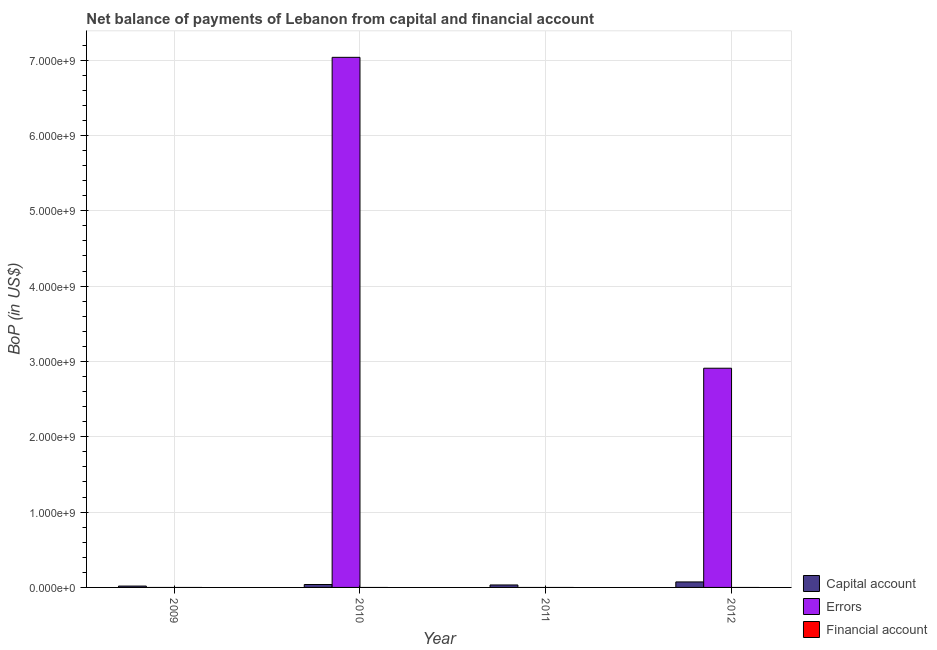Are the number of bars per tick equal to the number of legend labels?
Your answer should be very brief. No. Are the number of bars on each tick of the X-axis equal?
Make the answer very short. No. Across all years, what is the maximum amount of errors?
Keep it short and to the point. 7.04e+09. Across all years, what is the minimum amount of net capital account?
Offer a very short reply. 1.80e+07. What is the total amount of financial account in the graph?
Make the answer very short. 0. What is the difference between the amount of errors in 2010 and that in 2012?
Provide a succinct answer. 4.13e+09. What is the average amount of net capital account per year?
Your answer should be very brief. 4.07e+07. In the year 2009, what is the difference between the amount of net capital account and amount of financial account?
Offer a terse response. 0. In how many years, is the amount of net capital account greater than 1000000000 US$?
Your answer should be compact. 0. What is the ratio of the amount of net capital account in 2010 to that in 2011?
Give a very brief answer. 1.18. What is the difference between the highest and the lowest amount of errors?
Your response must be concise. 7.04e+09. In how many years, is the amount of financial account greater than the average amount of financial account taken over all years?
Keep it short and to the point. 0. Is it the case that in every year, the sum of the amount of net capital account and amount of errors is greater than the amount of financial account?
Offer a very short reply. Yes. Are all the bars in the graph horizontal?
Provide a succinct answer. No. How many years are there in the graph?
Make the answer very short. 4. What is the difference between two consecutive major ticks on the Y-axis?
Provide a short and direct response. 1.00e+09. Where does the legend appear in the graph?
Offer a very short reply. Bottom right. How many legend labels are there?
Your answer should be very brief. 3. What is the title of the graph?
Your answer should be compact. Net balance of payments of Lebanon from capital and financial account. Does "Renewable sources" appear as one of the legend labels in the graph?
Ensure brevity in your answer.  No. What is the label or title of the Y-axis?
Provide a short and direct response. BoP (in US$). What is the BoP (in US$) in Capital account in 2009?
Offer a terse response. 1.80e+07. What is the BoP (in US$) in Errors in 2009?
Offer a very short reply. 0. What is the BoP (in US$) in Capital account in 2010?
Offer a very short reply. 3.88e+07. What is the BoP (in US$) of Errors in 2010?
Ensure brevity in your answer.  7.04e+09. What is the BoP (in US$) in Capital account in 2011?
Offer a terse response. 3.28e+07. What is the BoP (in US$) in Errors in 2011?
Your response must be concise. 0. What is the BoP (in US$) of Capital account in 2012?
Your response must be concise. 7.31e+07. What is the BoP (in US$) of Errors in 2012?
Your answer should be compact. 2.91e+09. What is the BoP (in US$) in Financial account in 2012?
Ensure brevity in your answer.  0. Across all years, what is the maximum BoP (in US$) in Capital account?
Your answer should be very brief. 7.31e+07. Across all years, what is the maximum BoP (in US$) of Errors?
Your answer should be compact. 7.04e+09. Across all years, what is the minimum BoP (in US$) in Capital account?
Ensure brevity in your answer.  1.80e+07. Across all years, what is the minimum BoP (in US$) of Errors?
Give a very brief answer. 0. What is the total BoP (in US$) in Capital account in the graph?
Make the answer very short. 1.63e+08. What is the total BoP (in US$) of Errors in the graph?
Provide a succinct answer. 9.95e+09. What is the total BoP (in US$) of Financial account in the graph?
Provide a succinct answer. 0. What is the difference between the BoP (in US$) in Capital account in 2009 and that in 2010?
Your answer should be very brief. -2.09e+07. What is the difference between the BoP (in US$) in Capital account in 2009 and that in 2011?
Offer a very short reply. -1.48e+07. What is the difference between the BoP (in US$) in Capital account in 2009 and that in 2012?
Make the answer very short. -5.51e+07. What is the difference between the BoP (in US$) of Capital account in 2010 and that in 2011?
Provide a succinct answer. 6.05e+06. What is the difference between the BoP (in US$) in Capital account in 2010 and that in 2012?
Provide a succinct answer. -3.42e+07. What is the difference between the BoP (in US$) of Errors in 2010 and that in 2012?
Offer a very short reply. 4.13e+09. What is the difference between the BoP (in US$) of Capital account in 2011 and that in 2012?
Provide a short and direct response. -4.03e+07. What is the difference between the BoP (in US$) of Capital account in 2009 and the BoP (in US$) of Errors in 2010?
Your answer should be very brief. -7.02e+09. What is the difference between the BoP (in US$) of Capital account in 2009 and the BoP (in US$) of Errors in 2012?
Keep it short and to the point. -2.89e+09. What is the difference between the BoP (in US$) in Capital account in 2010 and the BoP (in US$) in Errors in 2012?
Ensure brevity in your answer.  -2.87e+09. What is the difference between the BoP (in US$) in Capital account in 2011 and the BoP (in US$) in Errors in 2012?
Offer a terse response. -2.88e+09. What is the average BoP (in US$) of Capital account per year?
Ensure brevity in your answer.  4.07e+07. What is the average BoP (in US$) of Errors per year?
Make the answer very short. 2.49e+09. In the year 2010, what is the difference between the BoP (in US$) in Capital account and BoP (in US$) in Errors?
Your answer should be compact. -7.00e+09. In the year 2012, what is the difference between the BoP (in US$) of Capital account and BoP (in US$) of Errors?
Your answer should be very brief. -2.84e+09. What is the ratio of the BoP (in US$) in Capital account in 2009 to that in 2010?
Provide a short and direct response. 0.46. What is the ratio of the BoP (in US$) of Capital account in 2009 to that in 2011?
Your answer should be compact. 0.55. What is the ratio of the BoP (in US$) in Capital account in 2009 to that in 2012?
Make the answer very short. 0.25. What is the ratio of the BoP (in US$) of Capital account in 2010 to that in 2011?
Ensure brevity in your answer.  1.18. What is the ratio of the BoP (in US$) in Capital account in 2010 to that in 2012?
Make the answer very short. 0.53. What is the ratio of the BoP (in US$) of Errors in 2010 to that in 2012?
Offer a terse response. 2.42. What is the ratio of the BoP (in US$) of Capital account in 2011 to that in 2012?
Keep it short and to the point. 0.45. What is the difference between the highest and the second highest BoP (in US$) in Capital account?
Keep it short and to the point. 3.42e+07. What is the difference between the highest and the lowest BoP (in US$) in Capital account?
Offer a very short reply. 5.51e+07. What is the difference between the highest and the lowest BoP (in US$) of Errors?
Make the answer very short. 7.04e+09. 